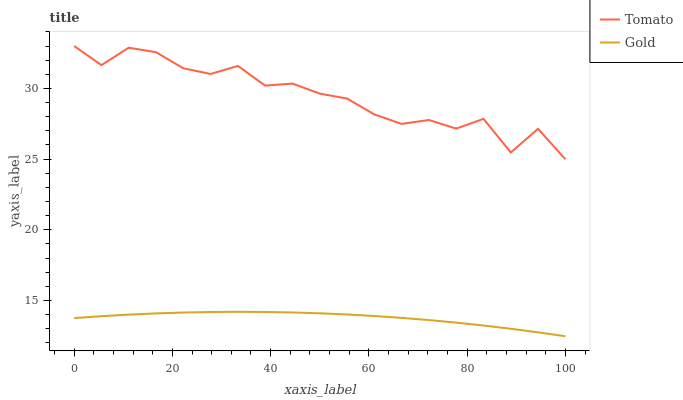Does Gold have the minimum area under the curve?
Answer yes or no. Yes. Does Tomato have the maximum area under the curve?
Answer yes or no. Yes. Does Gold have the maximum area under the curve?
Answer yes or no. No. Is Gold the smoothest?
Answer yes or no. Yes. Is Tomato the roughest?
Answer yes or no. Yes. Is Gold the roughest?
Answer yes or no. No. Does Gold have the lowest value?
Answer yes or no. Yes. Does Tomato have the highest value?
Answer yes or no. Yes. Does Gold have the highest value?
Answer yes or no. No. Is Gold less than Tomato?
Answer yes or no. Yes. Is Tomato greater than Gold?
Answer yes or no. Yes. Does Gold intersect Tomato?
Answer yes or no. No. 